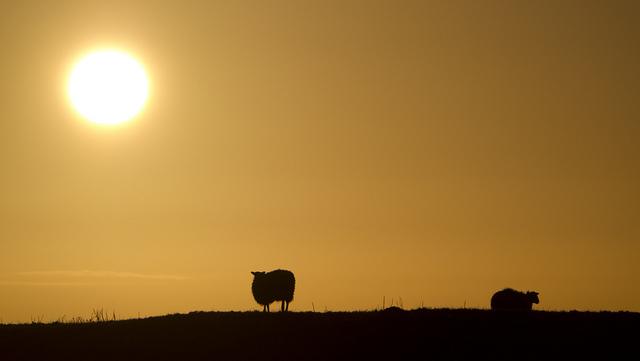Is the photo in color?
Keep it brief. Yes. How many animals are there?
Answer briefly. 2. What time of day is it?
Be succinct. Sunset. Is it night time?
Write a very short answer. No. What is the color of the background?
Be succinct. Yellow. 